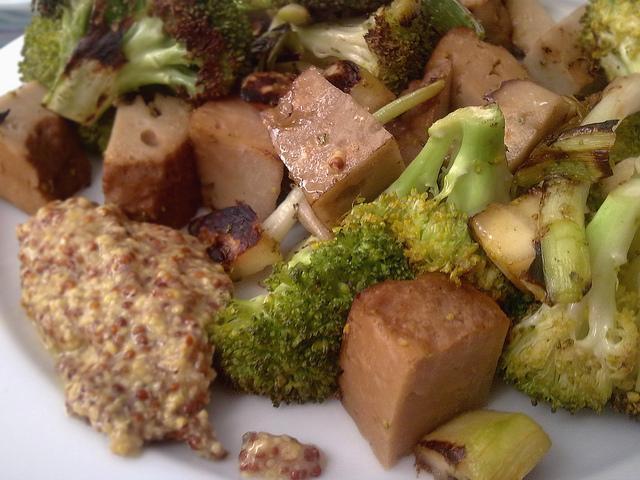How many plates are there?
Give a very brief answer. 1. How many broccolis are in the picture?
Give a very brief answer. 6. 